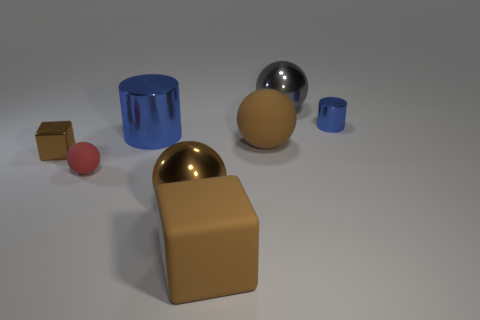The other block that is the same color as the small block is what size?
Your response must be concise. Large. What shape is the large metal object that is the same color as the tiny shiny cube?
Provide a succinct answer. Sphere. Is the number of brown matte things greater than the number of green matte cubes?
Your answer should be very brief. Yes. What is the small ball made of?
Provide a short and direct response. Rubber. How many other objects are the same material as the gray ball?
Keep it short and to the point. 4. How many small blue shiny things are there?
Your answer should be compact. 1. There is a large gray thing that is the same shape as the red matte object; what material is it?
Ensure brevity in your answer.  Metal. Are the object that is right of the gray ball and the large gray thing made of the same material?
Your response must be concise. Yes. Is the number of blue metal cylinders that are left of the big matte ball greater than the number of tiny brown blocks that are behind the tiny shiny cylinder?
Your response must be concise. Yes. The gray shiny thing has what size?
Your answer should be compact. Large. 